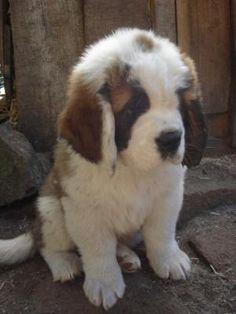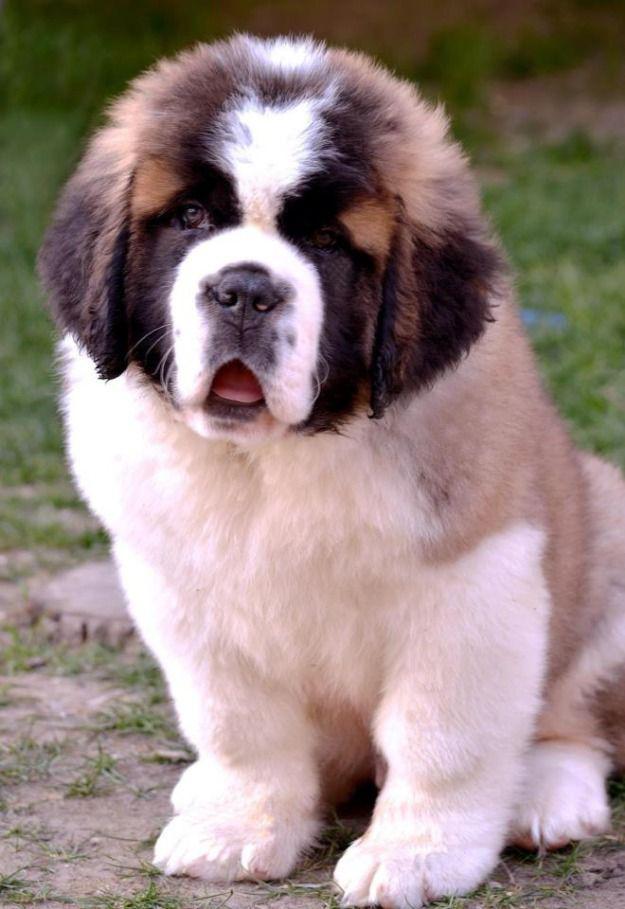The first image is the image on the left, the second image is the image on the right. Considering the images on both sides, is "There is two dogs in the left image." valid? Answer yes or no. No. The first image is the image on the left, the second image is the image on the right. Evaluate the accuracy of this statement regarding the images: "Each image contains one fluffy young dog in a non-standing position, and all dogs are white with darker fur on their ears and around their eyes.". Is it true? Answer yes or no. Yes. 